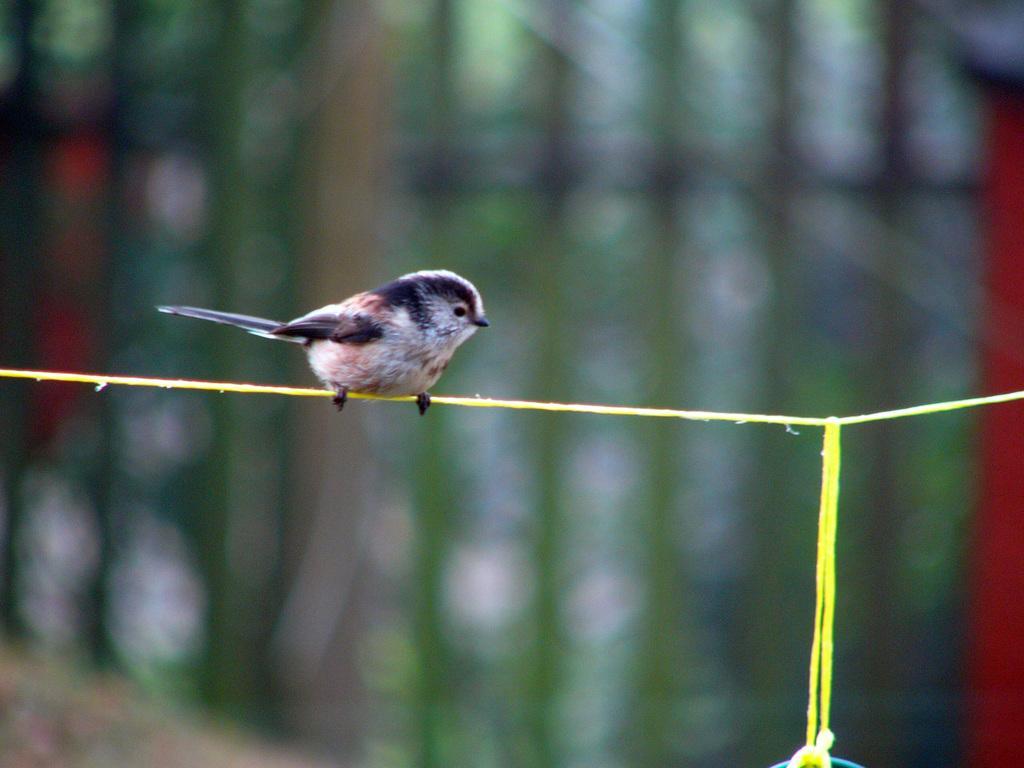How would you summarize this image in a sentence or two? In this picture I can see a bird on the rope. 